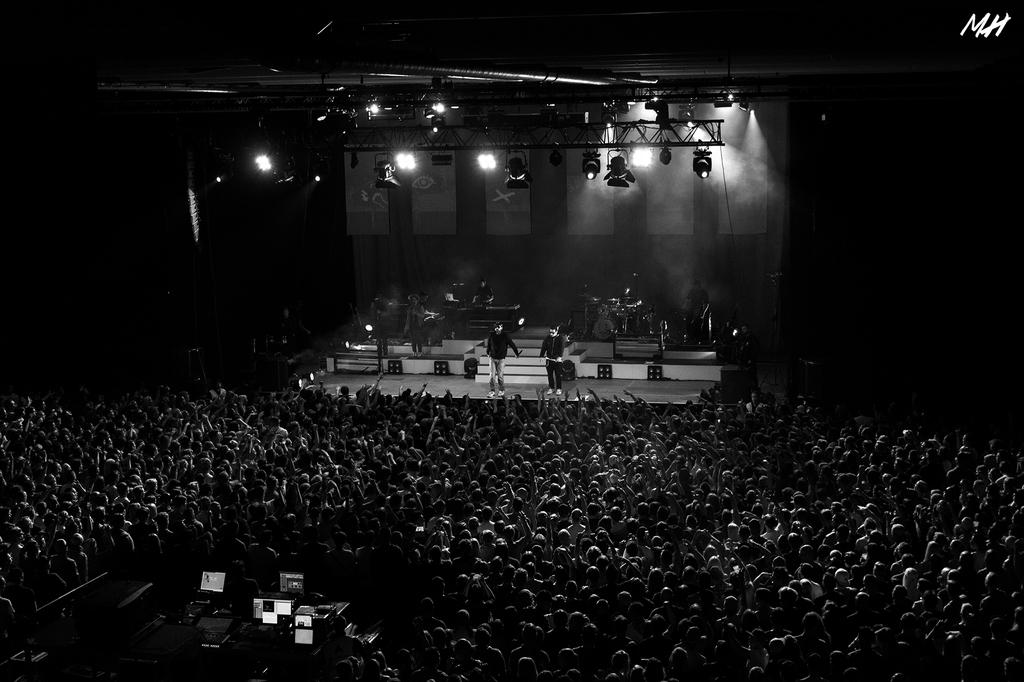What is the color scheme of the image? The image is black and white. What is happening on the stage in the image? There are people playing music instruments on a stage. How many people are visible in front of the stage? There are many people standing in front of the stage. What can be seen on the ceiling in the image? There are lights on the ceiling. How many cats are visible on the stage in the image? There are no cats visible on the stage in the image; it features people playing music instruments. What type of current is being used to power the lights on the ceiling? The image does not provide information about the type of current being used to power the lights on the ceiling. 